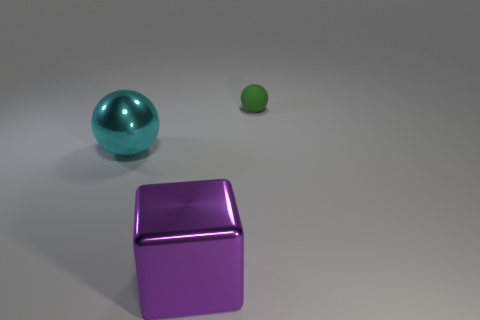Add 3 big cyan metal things. How many objects exist? 6 Subtract all balls. How many objects are left? 1 Add 3 green rubber objects. How many green rubber objects are left? 4 Add 1 metal cubes. How many metal cubes exist? 2 Subtract 0 blue cylinders. How many objects are left? 3 Subtract all blue matte balls. Subtract all shiny cubes. How many objects are left? 2 